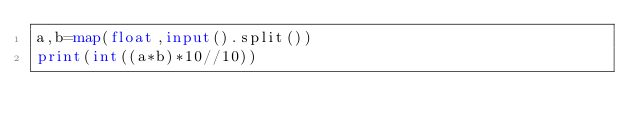Convert code to text. <code><loc_0><loc_0><loc_500><loc_500><_Python_>a,b=map(float,input().split())
print(int((a*b)*10//10))</code> 